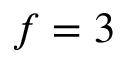Convert formula to latex. <formula><loc_0><loc_0><loc_500><loc_500>f = 3</formula> 